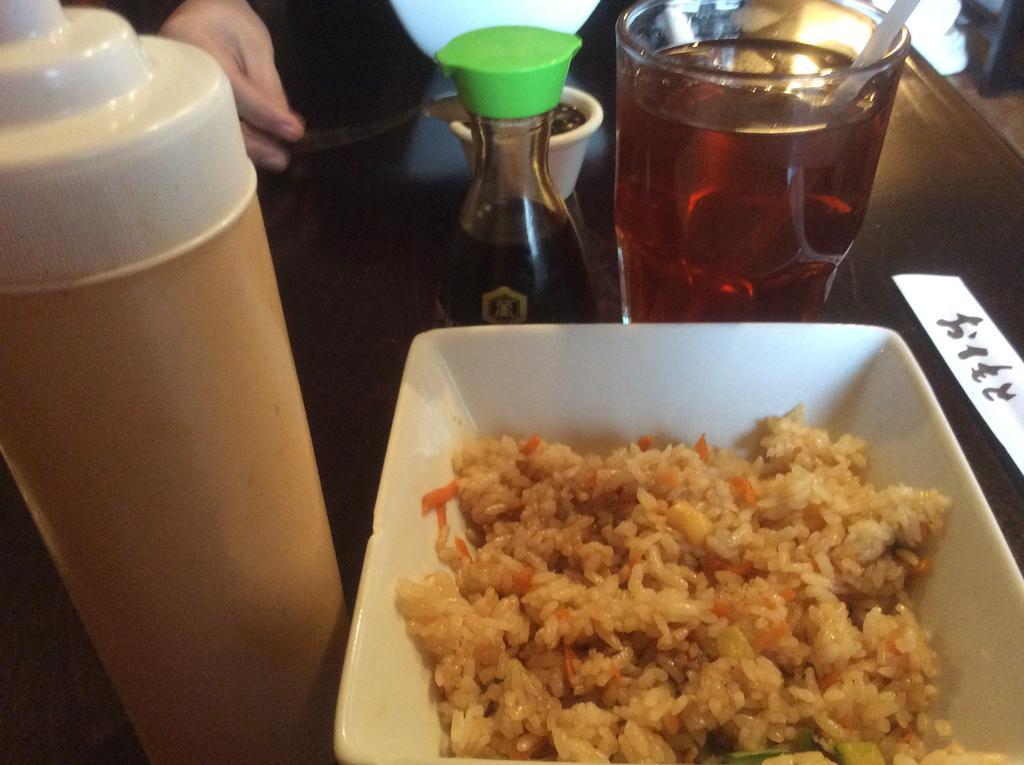How would you summarize this image in a sentence or two? In this image there is the table. On the table there is a food,glass, bottle, and hand of the person. 